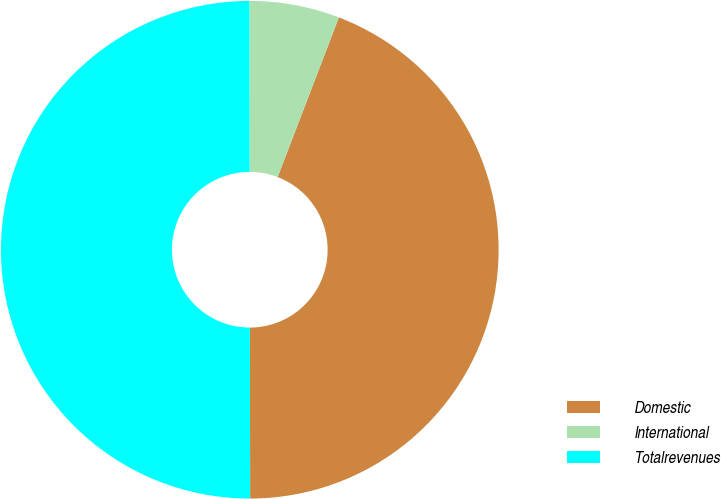Convert chart to OTSL. <chart><loc_0><loc_0><loc_500><loc_500><pie_chart><fcel>Domestic<fcel>International<fcel>Totalrevenues<nl><fcel>44.15%<fcel>5.85%<fcel>50.0%<nl></chart> 